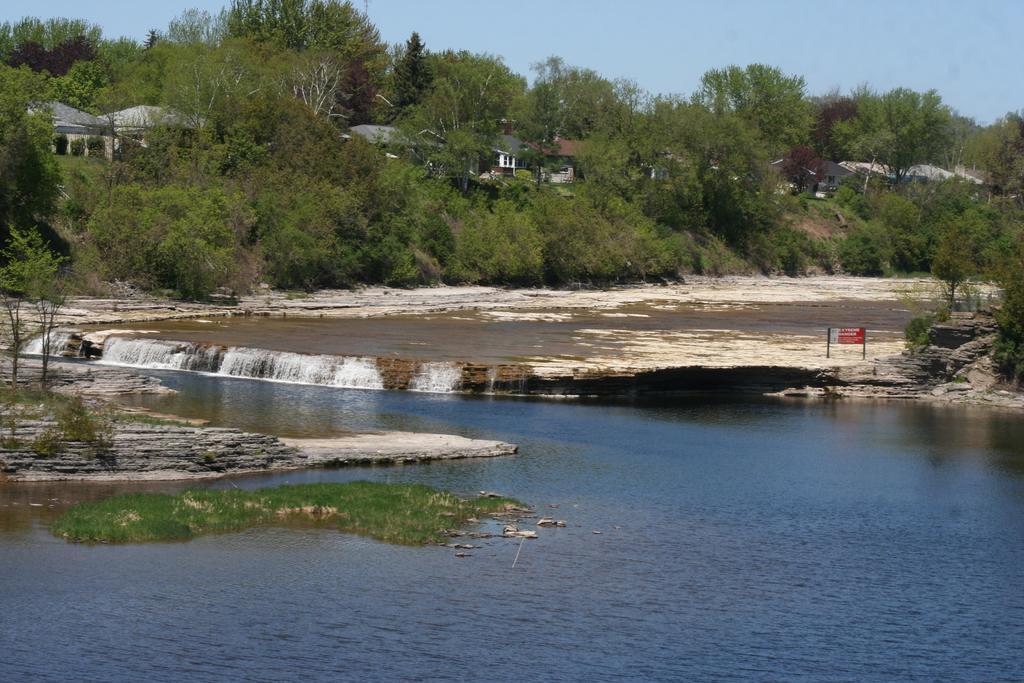Can you describe this image briefly? In this image we can see river, information board, trees, buildings and sky. 